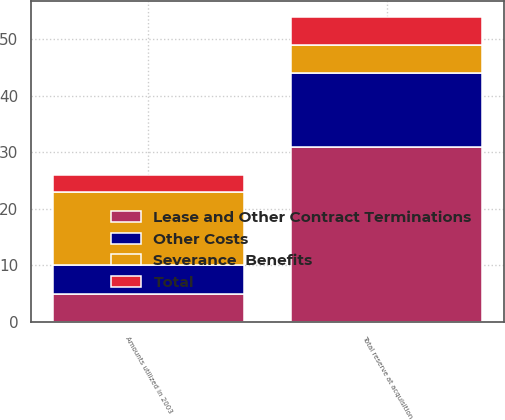Convert chart to OTSL. <chart><loc_0><loc_0><loc_500><loc_500><stacked_bar_chart><ecel><fcel>Total reserve at acquisition<fcel>Amounts utilized in 2003<nl><fcel>Other Costs<fcel>13<fcel>5<nl><fcel>Lease and Other Contract Terminations<fcel>31<fcel>5<nl><fcel>Total<fcel>5<fcel>3<nl><fcel>Severance  Benefits<fcel>5<fcel>13<nl></chart> 